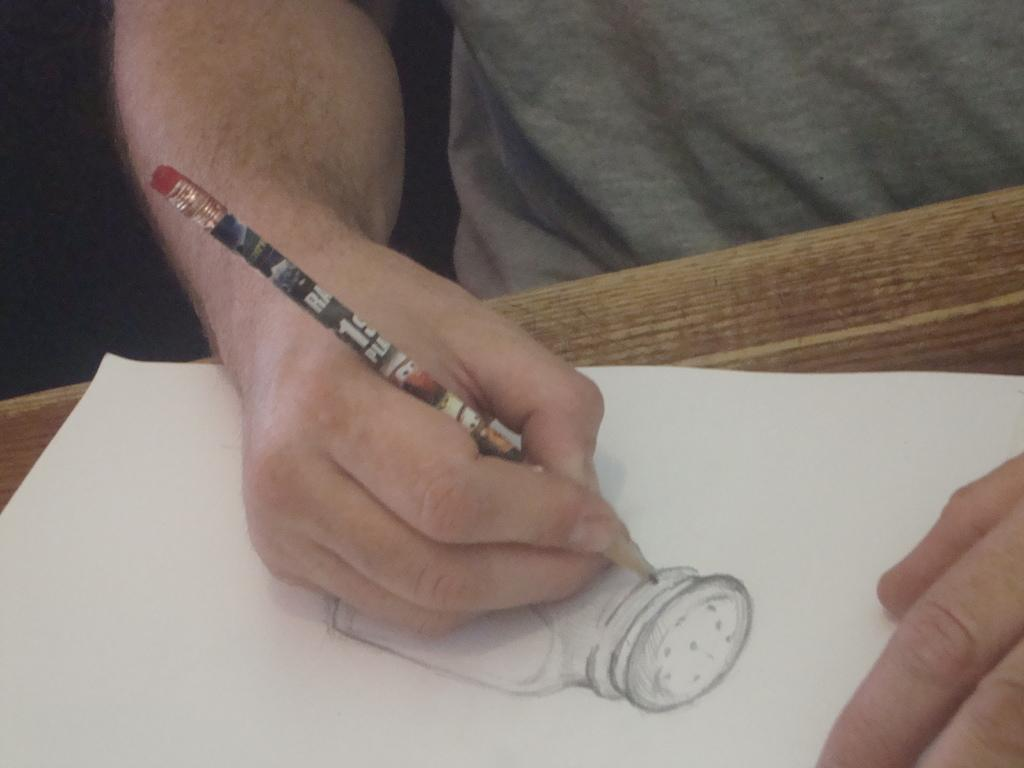What is the main subject of the image? There is a person in the image. What is the person holding in the image? The person is holding a pencil. What is the person doing with the pencil? The person is drawing on a paper. What type of bells can be heard ringing in the image? There are no bells present in the image, and therefore no sounds can be heard. 